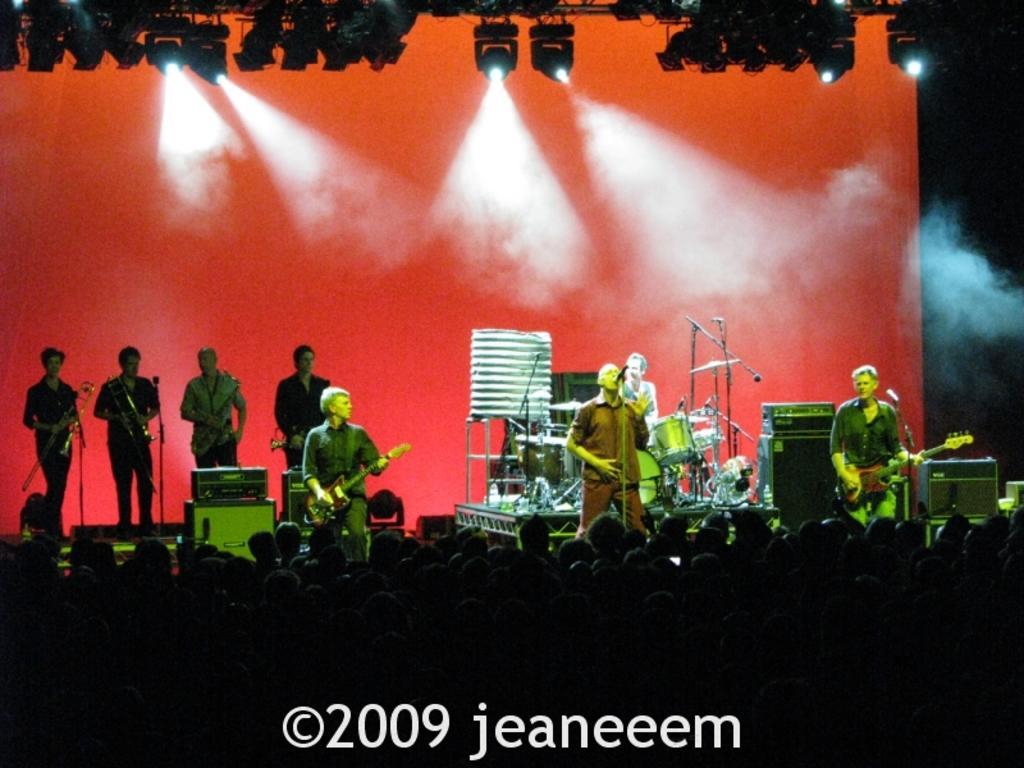Please provide a concise description of this image. In the center of the image there are people performing on the stage. At the bottom of the image there are people standing. In the background of the image there is a wall. 